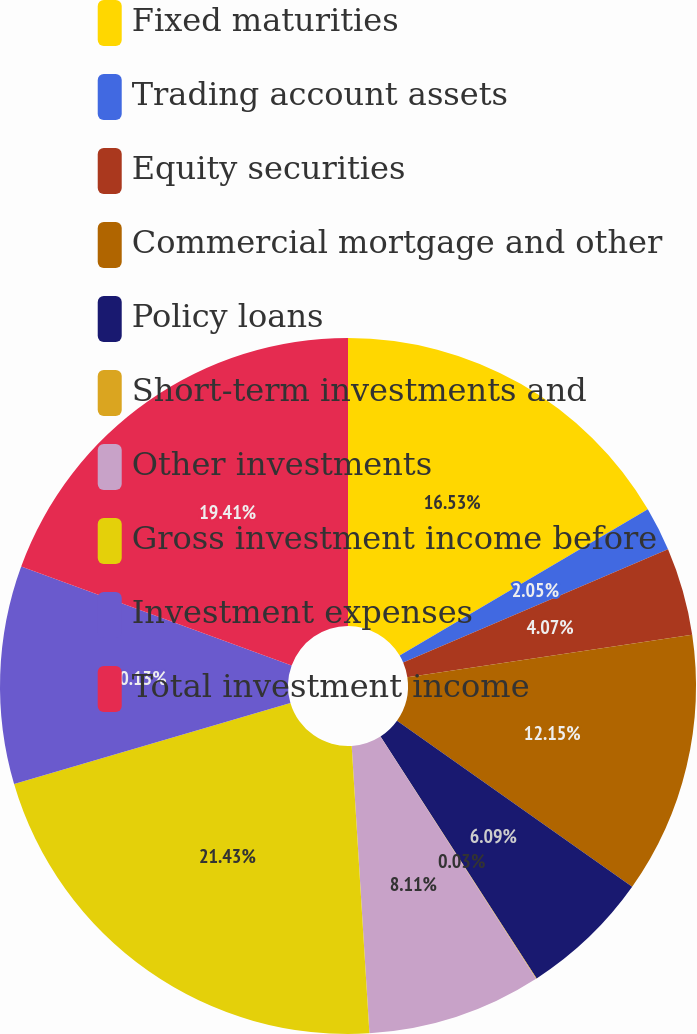Convert chart. <chart><loc_0><loc_0><loc_500><loc_500><pie_chart><fcel>Fixed maturities<fcel>Trading account assets<fcel>Equity securities<fcel>Commercial mortgage and other<fcel>Policy loans<fcel>Short-term investments and<fcel>Other investments<fcel>Gross investment income before<fcel>Investment expenses<fcel>Total investment income<nl><fcel>16.53%<fcel>2.05%<fcel>4.07%<fcel>12.15%<fcel>6.09%<fcel>0.03%<fcel>8.11%<fcel>21.44%<fcel>10.13%<fcel>19.42%<nl></chart> 